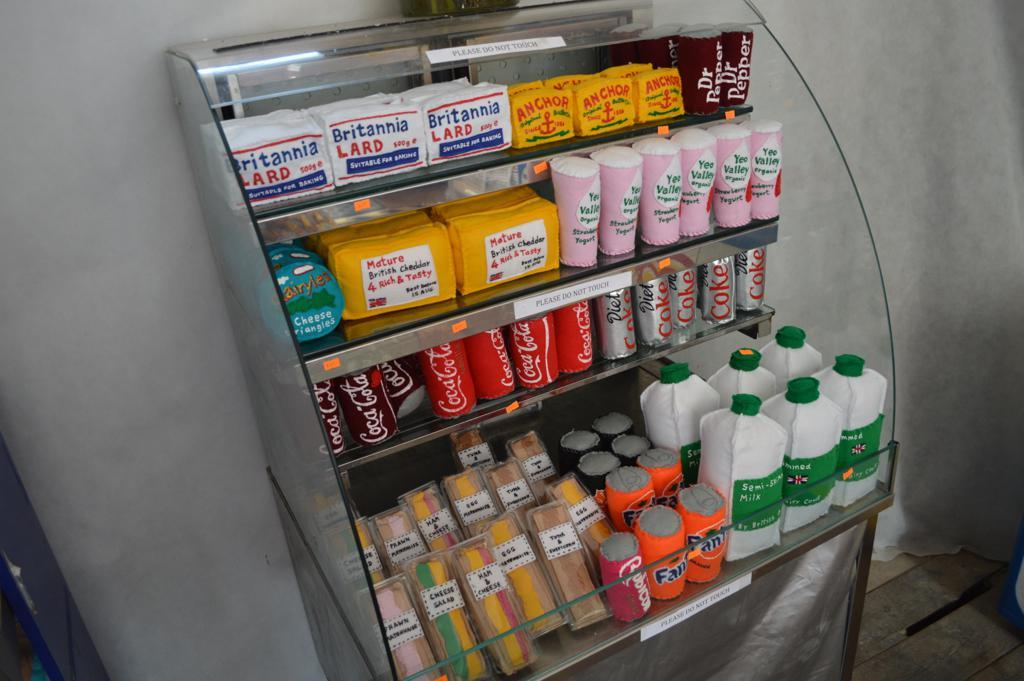<image>
Render a clear and concise summary of the photo. stand selling beverages including Coke and Britannia lard. 